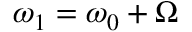<formula> <loc_0><loc_0><loc_500><loc_500>\omega _ { 1 } = \omega _ { 0 } + \Omega</formula> 